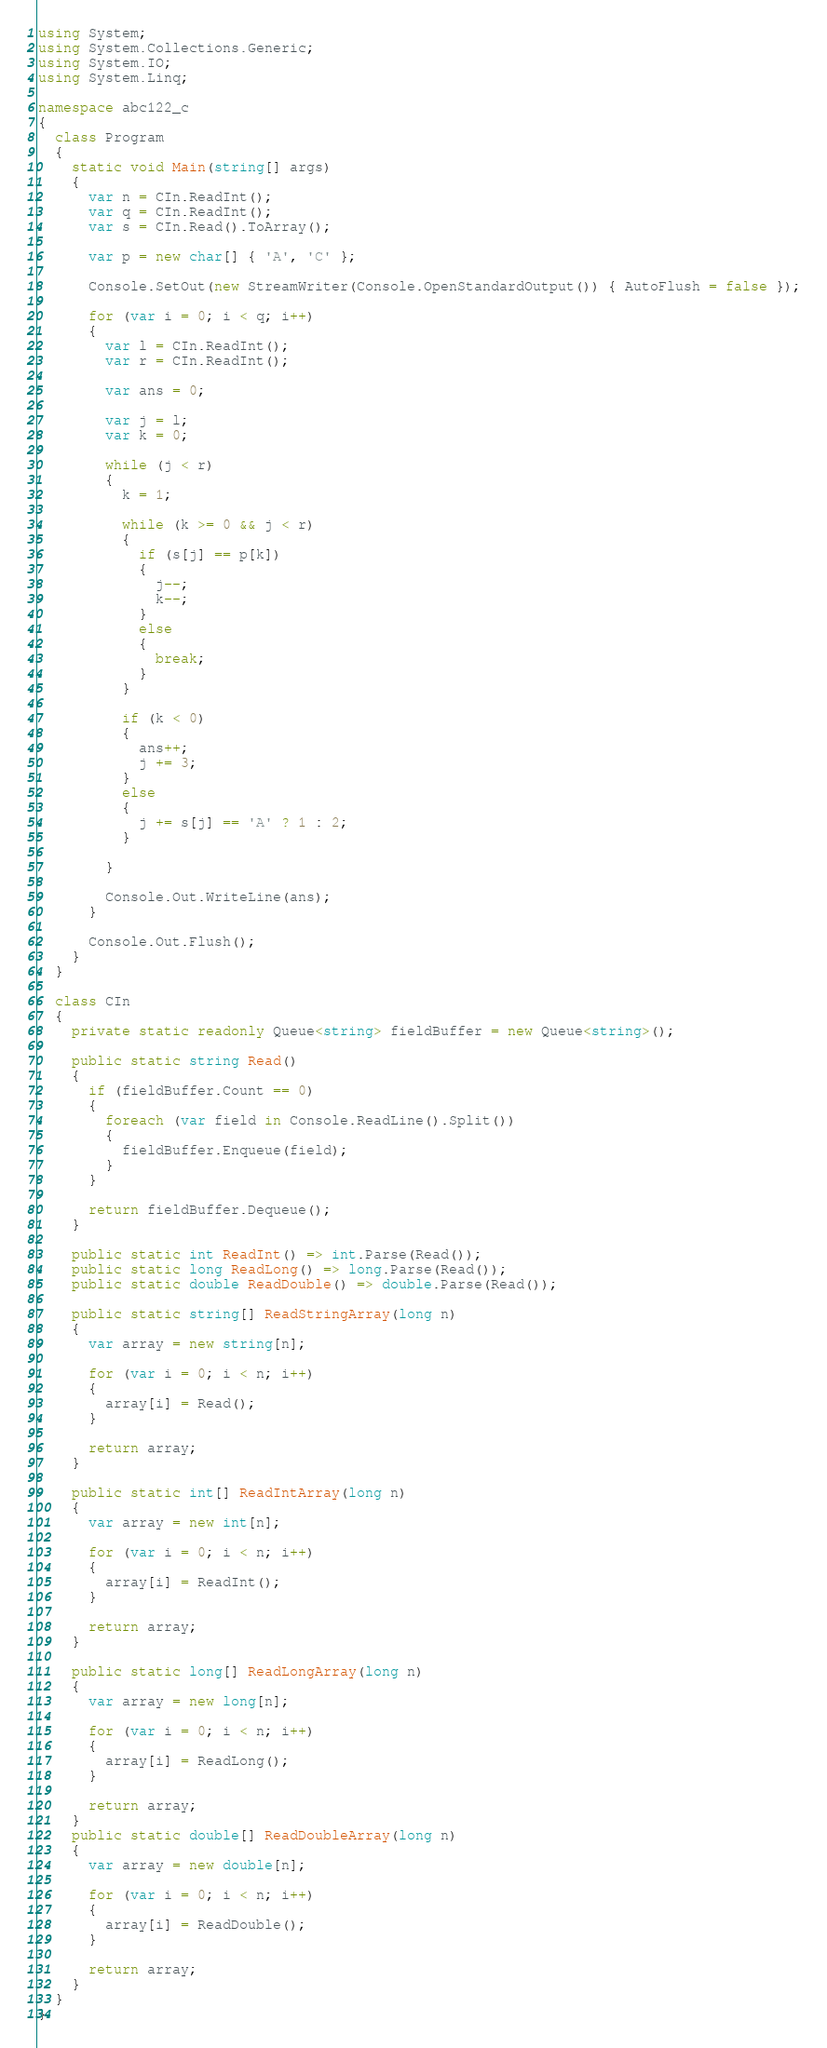Convert code to text. <code><loc_0><loc_0><loc_500><loc_500><_C#_>using System;
using System.Collections.Generic;
using System.IO;
using System.Linq;

namespace abc122_c
{
  class Program
  {
    static void Main(string[] args)
    {
      var n = CIn.ReadInt();
      var q = CIn.ReadInt();
      var s = CIn.Read().ToArray();

      var p = new char[] { 'A', 'C' };

      Console.SetOut(new StreamWriter(Console.OpenStandardOutput()) { AutoFlush = false });

      for (var i = 0; i < q; i++)
      {
        var l = CIn.ReadInt();
        var r = CIn.ReadInt();

        var ans = 0;

        var j = l;
        var k = 0;

        while (j < r)
        {
          k = 1;

          while (k >= 0 && j < r)
          {
            if (s[j] == p[k])
            {
              j--;
              k--;
            }
            else
            {
              break;
            }
          }

          if (k < 0)
          {
            ans++;
            j += 3;
          }
          else
          {
            j += s[j] == 'A' ? 1 : 2;
          }

        }

        Console.Out.WriteLine(ans);
      }

      Console.Out.Flush();
    }
  }

  class CIn
  {
    private static readonly Queue<string> fieldBuffer = new Queue<string>();

    public static string Read()
    {
      if (fieldBuffer.Count == 0)
      {
        foreach (var field in Console.ReadLine().Split())
        {
          fieldBuffer.Enqueue(field);
        }
      }

      return fieldBuffer.Dequeue();
    }

    public static int ReadInt() => int.Parse(Read());
    public static long ReadLong() => long.Parse(Read());
    public static double ReadDouble() => double.Parse(Read());

    public static string[] ReadStringArray(long n)
    {
      var array = new string[n];

      for (var i = 0; i < n; i++)
      {
        array[i] = Read();
      }

      return array;
    }

    public static int[] ReadIntArray(long n)
    {
      var array = new int[n];

      for (var i = 0; i < n; i++)
      {
        array[i] = ReadInt();
      }

      return array;
    }

    public static long[] ReadLongArray(long n)
    {
      var array = new long[n];

      for (var i = 0; i < n; i++)
      {
        array[i] = ReadLong();
      }

      return array;
    }
    public static double[] ReadDoubleArray(long n)
    {
      var array = new double[n];

      for (var i = 0; i < n; i++)
      {
        array[i] = ReadDouble();
      }

      return array;
    }
  }
}</code> 